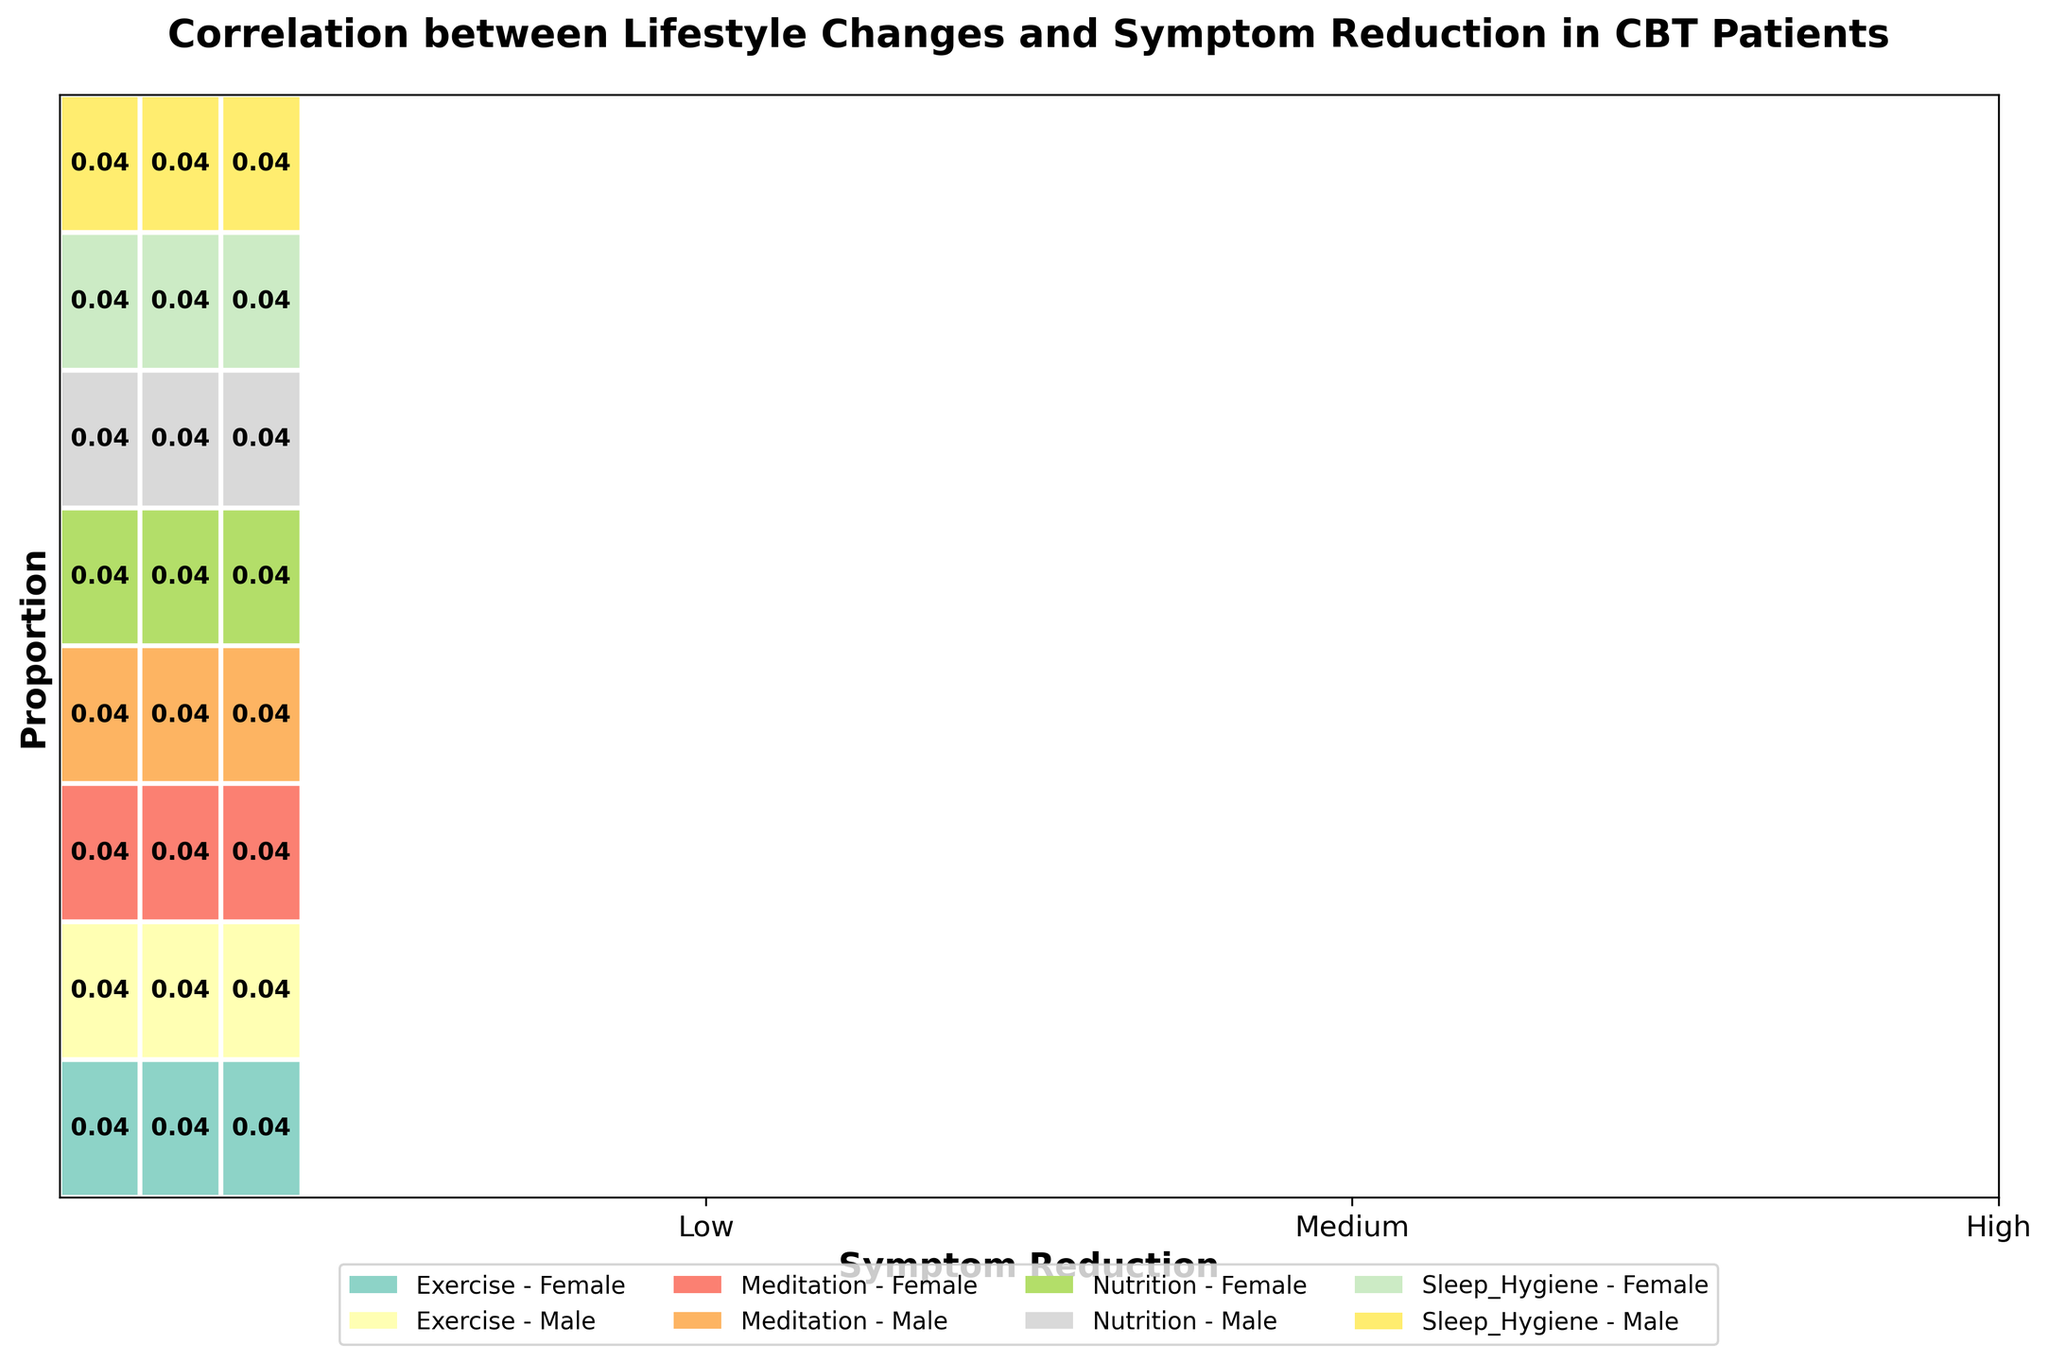Which lifestyle change shows the highest symptom reduction in females? According to the figure, you can see that "Exercise" and "Meditation" both have a "High" proportion for symptom reduction among females. Both of these lifestyle changes yield the highest symptom reduction in females.
Answer: Exercise, Meditation What is the overall trend for males in terms of symptom reduction? Observing the rectangles corresponding to males across different lifestyle changes, it can be seen that "High" symptom reduction occupies a significant portion for "Exercise" and "Meditation", showing that these changes yield high symptom reduction in males.
Answer: High How does the symptom reduction associated with "Sleep Hygiene" compare between genders? Comparing the rectangles for "Sleep Hygiene" between males and females, we can see that the proportions for "High", "Medium", and "Low" symptom reduction are roughly similar for both genders. Thus, the symptom reduction associated with "Sleep Hygiene" is comparable between genders.
Answer: Comparable Which gender shows a higher proportion of "Low" symptom reduction when practicing "Nutrition"? By looking at the rectangles for "Low" symptom reduction in "Nutrition", it is evident that both males and females show similar sizes, indicating that neither gender shows a remarkably higher proportion.
Answer: Similar What is the total proportion of "High" symptom reduction for both males and females combined? By summing up the widths of the rectangles for "High" symptom reduction across all lifestyle changes for both genders, we get a combined estimate. This task is simplified by the xticks showing a rough distribution, indicating a predominant proportion for "High".
Answer: Predominant Is there any lifestyle change where "Medium" symptom reduction is most prominent? Observing the visual representation of "Medium" symptom reduction, it is evident that "Sleep Hygiene" shows a larger width of the "Medium" proportion compared to other lifestyle changes.
Answer: Sleep Hygiene Which lifestyle change has the lowest symptom reduction for both genders? The rectangles with the smallest portions across all symptom reductions are for "Nutrition" and "Low" symptom reduction. Thus, "Nutrition" shows the lowest symptom reduction for both genders.
Answer: Nutrition For which lifestyle change do males and females equally exhibit "Medium" symptom reduction? Comparing the rectangles for "Medium" symptom reduction, we see that "Meditation" shows nearly equal proportions between males and females.
Answer: Meditation 